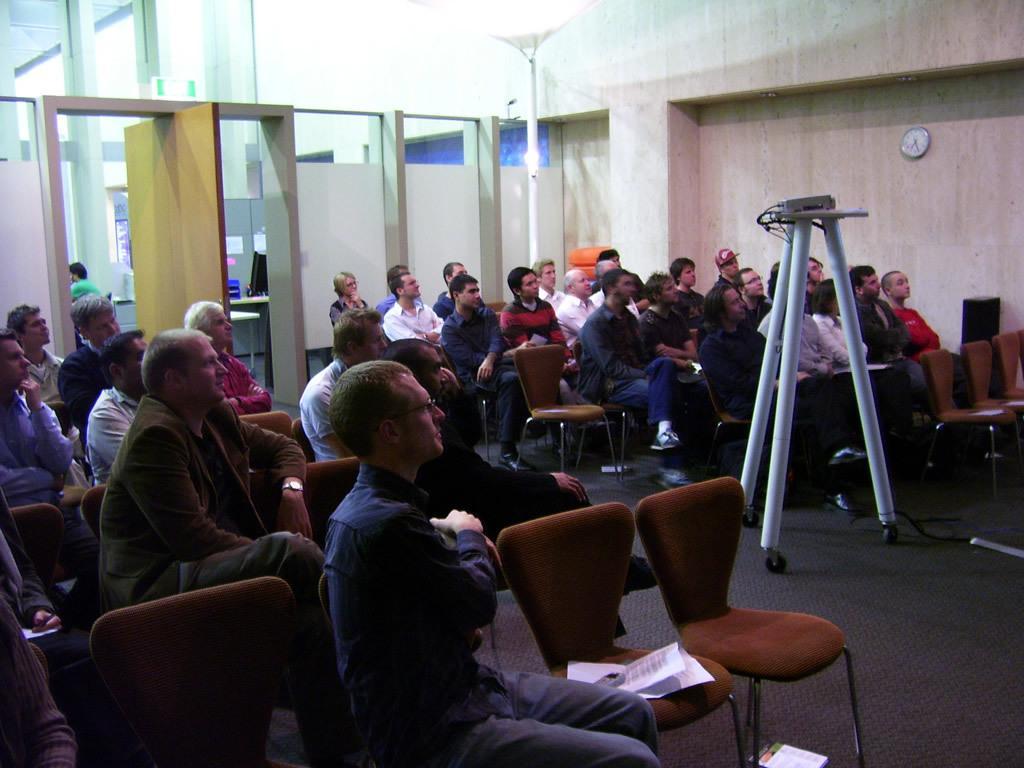Can you describe this image briefly? In this picture we can see a group of people sitting on chair and looking at some thing and in between them there is a stand with projector on it and in background we can see door, wall, watch , some person inside the room. 